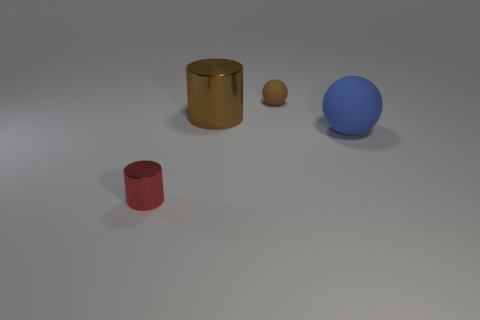Add 2 small gray rubber cubes. How many objects exist? 6 Subtract all blue spheres. How many spheres are left? 1 Add 4 balls. How many balls exist? 6 Subtract 0 cyan balls. How many objects are left? 4 Subtract 1 spheres. How many spheres are left? 1 Subtract all yellow cylinders. Subtract all brown cubes. How many cylinders are left? 2 Subtract all big cylinders. Subtract all blue rubber balls. How many objects are left? 2 Add 1 tiny balls. How many tiny balls are left? 2 